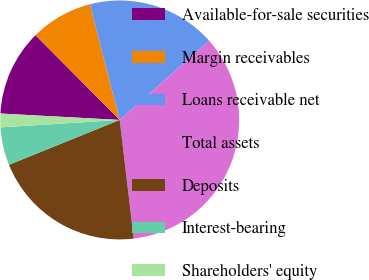Convert chart. <chart><loc_0><loc_0><loc_500><loc_500><pie_chart><fcel>Available-for-sale securities<fcel>Margin receivables<fcel>Loans receivable net<fcel>Total assets<fcel>Deposits<fcel>Interest-bearing<fcel>Shareholders' equity<nl><fcel>11.7%<fcel>8.42%<fcel>17.47%<fcel>34.68%<fcel>20.75%<fcel>5.13%<fcel>1.85%<nl></chart> 